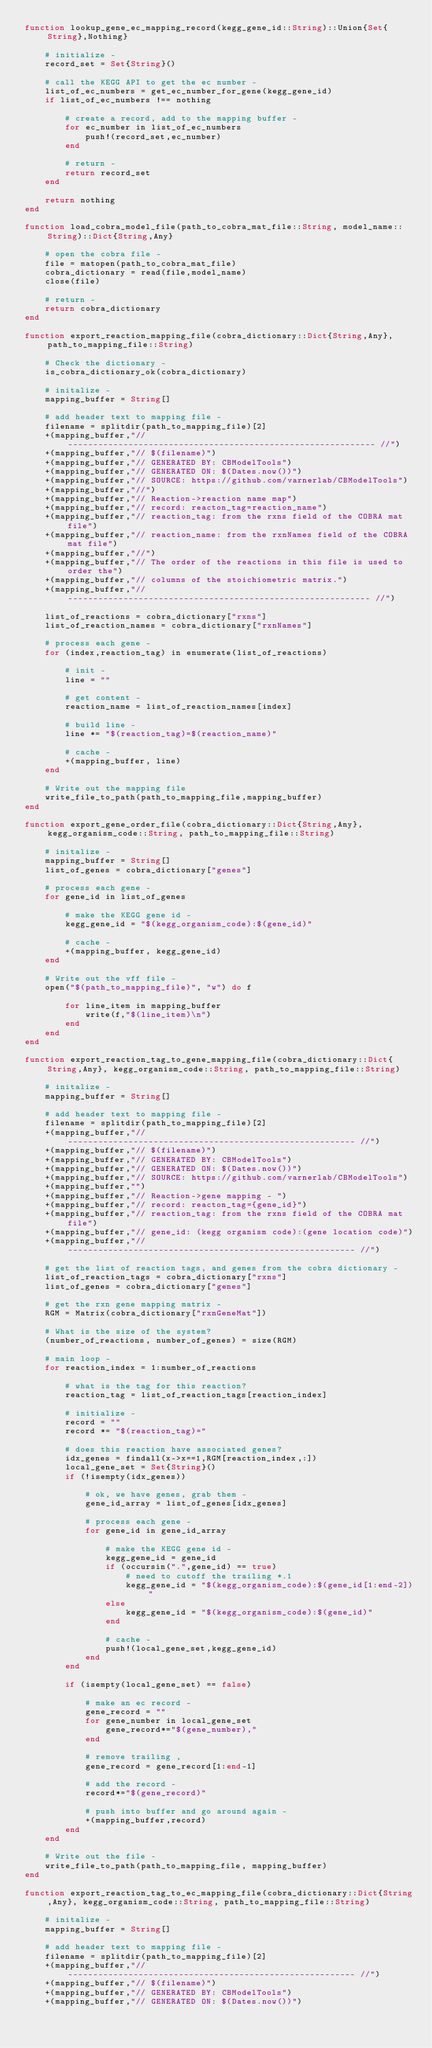<code> <loc_0><loc_0><loc_500><loc_500><_Julia_>function lookup_gene_ec_mapping_record(kegg_gene_id::String)::Union{Set{String},Nothing}

    # initialize -
    record_set = Set{String}()

    # call the KEGG API to get the ec number -
    list_of_ec_numbers = get_ec_number_for_gene(kegg_gene_id)
    if list_of_ec_numbers !== nothing

        # create a record, add to the mapping buffer -
        for ec_number in list_of_ec_numbers
            push!(record_set,ec_number)
        end

        # return -
        return record_set
    end

    return nothing
end

function load_cobra_model_file(path_to_cobra_mat_file::String, model_name::String)::Dict{String,Any}

    # open the cobra file -
    file = matopen(path_to_cobra_mat_file)
    cobra_dictionary = read(file,model_name)
    close(file)

    # return -
    return cobra_dictionary
end

function export_reaction_mapping_file(cobra_dictionary::Dict{String,Any}, path_to_mapping_file::String)

    # Check the dictionary -
    is_cobra_dictionary_ok(cobra_dictionary)

    # initalize -
    mapping_buffer = String[]

    # add header text to mapping file -
    filename = splitdir(path_to_mapping_file)[2]
    +(mapping_buffer,"// ------------------------------------------------------------- //")
    +(mapping_buffer,"// $(filename)")
    +(mapping_buffer,"// GENERATED BY: CBModelTools")
    +(mapping_buffer,"// GENERATED ON: $(Dates.now())")
    +(mapping_buffer,"// SOURCE: https://github.com/varnerlab/CBModelTools")
    +(mapping_buffer,"//")
    +(mapping_buffer,"// Reaction->reaction name map")
    +(mapping_buffer,"// record: reacton_tag=reaction_name")
    +(mapping_buffer,"// reaction_tag: from the rxns field of the COBRA mat file")
    +(mapping_buffer,"// reaction_name: from the rxnNames field of the COBRA mat file")
    +(mapping_buffer,"//")
    +(mapping_buffer,"// The order of the reactions in this file is used to order the")
    +(mapping_buffer,"// columns of the stoichiometric matrix.")
    +(mapping_buffer,"// ------------------------------------------------------------ //")

    list_of_reactions = cobra_dictionary["rxns"]
    list_of_reaction_names = cobra_dictionary["rxnNames"]

    # process each gene -
    for (index,reaction_tag) in enumerate(list_of_reactions)

        # init -
        line = ""

        # get content -
        reaction_name = list_of_reaction_names[index]

        # build line -
        line *= "$(reaction_tag)=$(reaction_name)"

        # cache -
        +(mapping_buffer, line)
    end

    # Write out the mapping file
    write_file_to_path(path_to_mapping_file,mapping_buffer)
end

function export_gene_order_file(cobra_dictionary::Dict{String,Any}, kegg_organism_code::String, path_to_mapping_file::String)

    # initalize -
    mapping_buffer = String[]
    list_of_genes = cobra_dictionary["genes"]

    # process each gene -
    for gene_id in list_of_genes

        # make the KEGG gene id -
        kegg_gene_id = "$(kegg_organism_code):$(gene_id)"

        # cache -
        +(mapping_buffer, kegg_gene_id)
    end

    # Write out the vff file -
    open("$(path_to_mapping_file)", "w") do f

        for line_item in mapping_buffer
            write(f,"$(line_item)\n")
        end
    end
end

function export_reaction_tag_to_gene_mapping_file(cobra_dictionary::Dict{String,Any}, kegg_organism_code::String, path_to_mapping_file::String)

    # initalize -
    mapping_buffer = String[]

    # add header text to mapping file -
    filename = splitdir(path_to_mapping_file)[2]
    +(mapping_buffer,"// --------------------------------------------------------- //")
    +(mapping_buffer,"// $(filename)")
    +(mapping_buffer,"// GENERATED BY: CBModelTools")
    +(mapping_buffer,"// GENERATED ON: $(Dates.now())")
    +(mapping_buffer,"// SOURCE: https://github.com/varnerlab/CBModelTools")
    +(mapping_buffer,"")
    +(mapping_buffer,"// Reaction->gene mapping - ")
    +(mapping_buffer,"// record: reacton_tag={gene_id}")
    +(mapping_buffer,"// reaction_tag: from the rxns field of the COBRA mat file")
    +(mapping_buffer,"// gene_id: (kegg organism code):(gene location code)")
    +(mapping_buffer,"// --------------------------------------------------------- //")

    # get the list of reaction tags, and genes from the cobra dictionary -
    list_of_reaction_tags = cobra_dictionary["rxns"]
    list_of_genes = cobra_dictionary["genes"]

    # get the rxn gene mapping matrix -
    RGM = Matrix(cobra_dictionary["rxnGeneMat"])

    # What is the size of the system?
    (number_of_reactions, number_of_genes) = size(RGM)

    # main loop -
    for reaction_index = 1:number_of_reactions

        # what is the tag for this reaction?
        reaction_tag = list_of_reaction_tags[reaction_index]

        # initialize -
        record = ""
        record *= "$(reaction_tag)="

        # does this reaction have associated genes?
        idx_genes = findall(x->x==1,RGM[reaction_index,:])
        local_gene_set = Set{String}()
        if (!isempty(idx_genes))

            # ok, we have genes, grab them -
            gene_id_array = list_of_genes[idx_genes]

            # process each gene -
            for gene_id in gene_id_array

                # make the KEGG gene id -
                kegg_gene_id = gene_id
                if (occursin(".",gene_id) == true)
                    # need to cutoff the trailing *.1
                    kegg_gene_id = "$(kegg_organism_code):$(gene_id[1:end-2])"
                else
                    kegg_gene_id = "$(kegg_organism_code):$(gene_id)"
                end

                # cache -
                push!(local_gene_set,kegg_gene_id)
            end
        end

        if (isempty(local_gene_set) == false)

            # make an ec record -
            gene_record = ""
            for gene_number in local_gene_set
                gene_record*="$(gene_number),"
            end

            # remove trailing ,
            gene_record = gene_record[1:end-1]

            # add the record -
            record*="$(gene_record)"

            # push into buffer and go around again -
            +(mapping_buffer,record)
        end
    end

    # Write out the file -
    write_file_to_path(path_to_mapping_file, mapping_buffer)
end

function export_reaction_tag_to_ec_mapping_file(cobra_dictionary::Dict{String,Any}, kegg_organism_code::String, path_to_mapping_file::String)

    # initalize -
    mapping_buffer = String[]

    # add header text to mapping file -
    filename = splitdir(path_to_mapping_file)[2]
    +(mapping_buffer,"// --------------------------------------------------------- //")
    +(mapping_buffer,"// $(filename)")
    +(mapping_buffer,"// GENERATED BY: CBModelTools")
    +(mapping_buffer,"// GENERATED ON: $(Dates.now())")</code> 